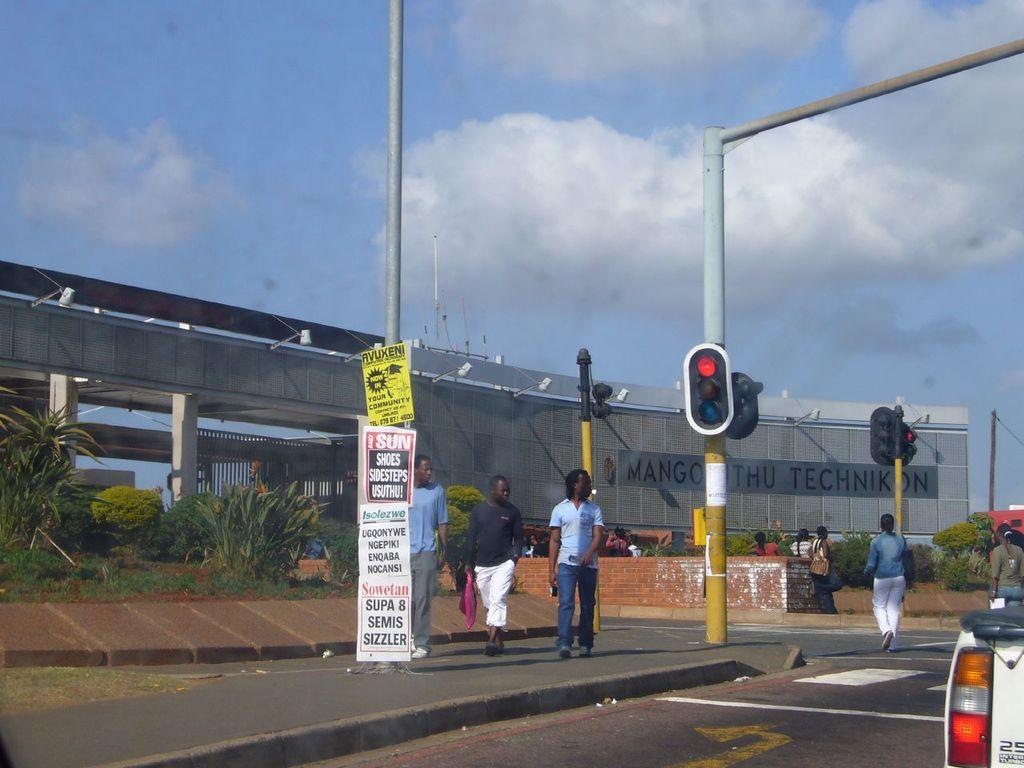What is the first word written on the building?
Your answer should be compact. Mango. All foreign language?
Offer a terse response. No. 